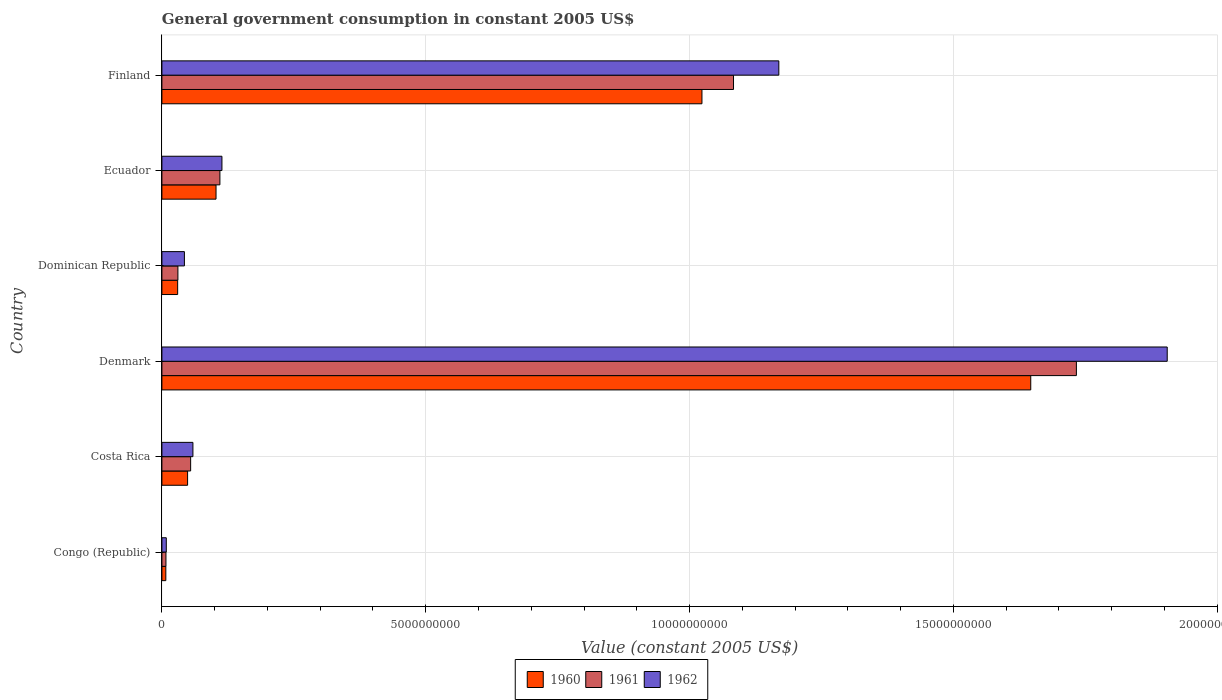How many different coloured bars are there?
Offer a very short reply. 3. How many groups of bars are there?
Your answer should be very brief. 6. How many bars are there on the 4th tick from the bottom?
Offer a very short reply. 3. In how many cases, is the number of bars for a given country not equal to the number of legend labels?
Your answer should be very brief. 0. What is the government conusmption in 1960 in Congo (Republic)?
Provide a succinct answer. 7.44e+07. Across all countries, what is the maximum government conusmption in 1961?
Provide a succinct answer. 1.73e+1. Across all countries, what is the minimum government conusmption in 1960?
Your response must be concise. 7.44e+07. In which country was the government conusmption in 1960 minimum?
Offer a very short reply. Congo (Republic). What is the total government conusmption in 1962 in the graph?
Your answer should be very brief. 3.30e+1. What is the difference between the government conusmption in 1961 in Congo (Republic) and that in Costa Rica?
Offer a very short reply. -4.68e+08. What is the difference between the government conusmption in 1962 in Denmark and the government conusmption in 1961 in Ecuador?
Offer a terse response. 1.80e+1. What is the average government conusmption in 1960 per country?
Offer a very short reply. 4.76e+09. What is the difference between the government conusmption in 1962 and government conusmption in 1960 in Dominican Republic?
Offer a very short reply. 1.28e+08. In how many countries, is the government conusmption in 1962 greater than 14000000000 US$?
Make the answer very short. 1. What is the ratio of the government conusmption in 1960 in Dominican Republic to that in Ecuador?
Offer a very short reply. 0.29. Is the government conusmption in 1960 in Costa Rica less than that in Denmark?
Offer a terse response. Yes. Is the difference between the government conusmption in 1962 in Dominican Republic and Ecuador greater than the difference between the government conusmption in 1960 in Dominican Republic and Ecuador?
Provide a succinct answer. Yes. What is the difference between the highest and the second highest government conusmption in 1962?
Provide a succinct answer. 7.36e+09. What is the difference between the highest and the lowest government conusmption in 1960?
Ensure brevity in your answer.  1.64e+1. In how many countries, is the government conusmption in 1960 greater than the average government conusmption in 1960 taken over all countries?
Make the answer very short. 2. What does the 3rd bar from the top in Dominican Republic represents?
Ensure brevity in your answer.  1960. How many countries are there in the graph?
Ensure brevity in your answer.  6. Are the values on the major ticks of X-axis written in scientific E-notation?
Provide a succinct answer. No. Does the graph contain any zero values?
Provide a short and direct response. No. Where does the legend appear in the graph?
Provide a succinct answer. Bottom center. What is the title of the graph?
Keep it short and to the point. General government consumption in constant 2005 US$. Does "1975" appear as one of the legend labels in the graph?
Offer a very short reply. No. What is the label or title of the X-axis?
Give a very brief answer. Value (constant 2005 US$). What is the Value (constant 2005 US$) of 1960 in Congo (Republic)?
Offer a very short reply. 7.44e+07. What is the Value (constant 2005 US$) in 1961 in Congo (Republic)?
Offer a very short reply. 7.67e+07. What is the Value (constant 2005 US$) in 1962 in Congo (Republic)?
Provide a succinct answer. 8.33e+07. What is the Value (constant 2005 US$) of 1960 in Costa Rica?
Your answer should be compact. 4.87e+08. What is the Value (constant 2005 US$) of 1961 in Costa Rica?
Your answer should be very brief. 5.45e+08. What is the Value (constant 2005 US$) of 1962 in Costa Rica?
Give a very brief answer. 5.88e+08. What is the Value (constant 2005 US$) in 1960 in Denmark?
Offer a very short reply. 1.65e+1. What is the Value (constant 2005 US$) in 1961 in Denmark?
Ensure brevity in your answer.  1.73e+1. What is the Value (constant 2005 US$) of 1962 in Denmark?
Your response must be concise. 1.91e+1. What is the Value (constant 2005 US$) of 1960 in Dominican Republic?
Provide a succinct answer. 2.99e+08. What is the Value (constant 2005 US$) of 1961 in Dominican Republic?
Your response must be concise. 3.03e+08. What is the Value (constant 2005 US$) of 1962 in Dominican Republic?
Offer a very short reply. 4.27e+08. What is the Value (constant 2005 US$) in 1960 in Ecuador?
Make the answer very short. 1.03e+09. What is the Value (constant 2005 US$) in 1961 in Ecuador?
Give a very brief answer. 1.10e+09. What is the Value (constant 2005 US$) in 1962 in Ecuador?
Your response must be concise. 1.14e+09. What is the Value (constant 2005 US$) of 1960 in Finland?
Provide a succinct answer. 1.02e+1. What is the Value (constant 2005 US$) in 1961 in Finland?
Provide a succinct answer. 1.08e+1. What is the Value (constant 2005 US$) of 1962 in Finland?
Offer a terse response. 1.17e+1. Across all countries, what is the maximum Value (constant 2005 US$) in 1960?
Keep it short and to the point. 1.65e+1. Across all countries, what is the maximum Value (constant 2005 US$) in 1961?
Provide a short and direct response. 1.73e+1. Across all countries, what is the maximum Value (constant 2005 US$) of 1962?
Your response must be concise. 1.91e+1. Across all countries, what is the minimum Value (constant 2005 US$) of 1960?
Make the answer very short. 7.44e+07. Across all countries, what is the minimum Value (constant 2005 US$) of 1961?
Ensure brevity in your answer.  7.67e+07. Across all countries, what is the minimum Value (constant 2005 US$) in 1962?
Ensure brevity in your answer.  8.33e+07. What is the total Value (constant 2005 US$) of 1960 in the graph?
Your answer should be very brief. 2.86e+1. What is the total Value (constant 2005 US$) of 1961 in the graph?
Provide a succinct answer. 3.02e+1. What is the total Value (constant 2005 US$) in 1962 in the graph?
Give a very brief answer. 3.30e+1. What is the difference between the Value (constant 2005 US$) of 1960 in Congo (Republic) and that in Costa Rica?
Keep it short and to the point. -4.12e+08. What is the difference between the Value (constant 2005 US$) of 1961 in Congo (Republic) and that in Costa Rica?
Offer a terse response. -4.68e+08. What is the difference between the Value (constant 2005 US$) of 1962 in Congo (Republic) and that in Costa Rica?
Provide a short and direct response. -5.05e+08. What is the difference between the Value (constant 2005 US$) in 1960 in Congo (Republic) and that in Denmark?
Offer a very short reply. -1.64e+1. What is the difference between the Value (constant 2005 US$) of 1961 in Congo (Republic) and that in Denmark?
Your answer should be very brief. -1.73e+1. What is the difference between the Value (constant 2005 US$) in 1962 in Congo (Republic) and that in Denmark?
Your answer should be very brief. -1.90e+1. What is the difference between the Value (constant 2005 US$) in 1960 in Congo (Republic) and that in Dominican Republic?
Offer a very short reply. -2.24e+08. What is the difference between the Value (constant 2005 US$) of 1961 in Congo (Republic) and that in Dominican Republic?
Your answer should be compact. -2.27e+08. What is the difference between the Value (constant 2005 US$) of 1962 in Congo (Republic) and that in Dominican Republic?
Your answer should be very brief. -3.43e+08. What is the difference between the Value (constant 2005 US$) of 1960 in Congo (Republic) and that in Ecuador?
Your response must be concise. -9.51e+08. What is the difference between the Value (constant 2005 US$) of 1961 in Congo (Republic) and that in Ecuador?
Your answer should be very brief. -1.02e+09. What is the difference between the Value (constant 2005 US$) of 1962 in Congo (Republic) and that in Ecuador?
Offer a terse response. -1.05e+09. What is the difference between the Value (constant 2005 US$) in 1960 in Congo (Republic) and that in Finland?
Offer a terse response. -1.02e+1. What is the difference between the Value (constant 2005 US$) of 1961 in Congo (Republic) and that in Finland?
Your answer should be compact. -1.08e+1. What is the difference between the Value (constant 2005 US$) in 1962 in Congo (Republic) and that in Finland?
Make the answer very short. -1.16e+1. What is the difference between the Value (constant 2005 US$) in 1960 in Costa Rica and that in Denmark?
Your response must be concise. -1.60e+1. What is the difference between the Value (constant 2005 US$) in 1961 in Costa Rica and that in Denmark?
Your answer should be very brief. -1.68e+1. What is the difference between the Value (constant 2005 US$) in 1962 in Costa Rica and that in Denmark?
Your answer should be very brief. -1.85e+1. What is the difference between the Value (constant 2005 US$) in 1960 in Costa Rica and that in Dominican Republic?
Your response must be concise. 1.88e+08. What is the difference between the Value (constant 2005 US$) in 1961 in Costa Rica and that in Dominican Republic?
Your answer should be very brief. 2.41e+08. What is the difference between the Value (constant 2005 US$) in 1962 in Costa Rica and that in Dominican Republic?
Your response must be concise. 1.61e+08. What is the difference between the Value (constant 2005 US$) in 1960 in Costa Rica and that in Ecuador?
Offer a terse response. -5.39e+08. What is the difference between the Value (constant 2005 US$) in 1961 in Costa Rica and that in Ecuador?
Provide a succinct answer. -5.55e+08. What is the difference between the Value (constant 2005 US$) of 1962 in Costa Rica and that in Ecuador?
Your response must be concise. -5.50e+08. What is the difference between the Value (constant 2005 US$) in 1960 in Costa Rica and that in Finland?
Offer a very short reply. -9.75e+09. What is the difference between the Value (constant 2005 US$) in 1961 in Costa Rica and that in Finland?
Keep it short and to the point. -1.03e+1. What is the difference between the Value (constant 2005 US$) in 1962 in Costa Rica and that in Finland?
Your answer should be very brief. -1.11e+1. What is the difference between the Value (constant 2005 US$) in 1960 in Denmark and that in Dominican Republic?
Keep it short and to the point. 1.62e+1. What is the difference between the Value (constant 2005 US$) in 1961 in Denmark and that in Dominican Republic?
Keep it short and to the point. 1.70e+1. What is the difference between the Value (constant 2005 US$) in 1962 in Denmark and that in Dominican Republic?
Offer a terse response. 1.86e+1. What is the difference between the Value (constant 2005 US$) of 1960 in Denmark and that in Ecuador?
Provide a short and direct response. 1.54e+1. What is the difference between the Value (constant 2005 US$) of 1961 in Denmark and that in Ecuador?
Your answer should be compact. 1.62e+1. What is the difference between the Value (constant 2005 US$) of 1962 in Denmark and that in Ecuador?
Offer a terse response. 1.79e+1. What is the difference between the Value (constant 2005 US$) of 1960 in Denmark and that in Finland?
Ensure brevity in your answer.  6.23e+09. What is the difference between the Value (constant 2005 US$) in 1961 in Denmark and that in Finland?
Offer a terse response. 6.50e+09. What is the difference between the Value (constant 2005 US$) in 1962 in Denmark and that in Finland?
Offer a very short reply. 7.36e+09. What is the difference between the Value (constant 2005 US$) of 1960 in Dominican Republic and that in Ecuador?
Keep it short and to the point. -7.27e+08. What is the difference between the Value (constant 2005 US$) in 1961 in Dominican Republic and that in Ecuador?
Provide a short and direct response. -7.96e+08. What is the difference between the Value (constant 2005 US$) of 1962 in Dominican Republic and that in Ecuador?
Make the answer very short. -7.11e+08. What is the difference between the Value (constant 2005 US$) of 1960 in Dominican Republic and that in Finland?
Your answer should be compact. -9.94e+09. What is the difference between the Value (constant 2005 US$) in 1961 in Dominican Republic and that in Finland?
Provide a short and direct response. -1.05e+1. What is the difference between the Value (constant 2005 US$) in 1962 in Dominican Republic and that in Finland?
Provide a succinct answer. -1.13e+1. What is the difference between the Value (constant 2005 US$) of 1960 in Ecuador and that in Finland?
Provide a succinct answer. -9.21e+09. What is the difference between the Value (constant 2005 US$) of 1961 in Ecuador and that in Finland?
Your answer should be compact. -9.73e+09. What is the difference between the Value (constant 2005 US$) in 1962 in Ecuador and that in Finland?
Give a very brief answer. -1.06e+1. What is the difference between the Value (constant 2005 US$) of 1960 in Congo (Republic) and the Value (constant 2005 US$) of 1961 in Costa Rica?
Offer a very short reply. -4.70e+08. What is the difference between the Value (constant 2005 US$) of 1960 in Congo (Republic) and the Value (constant 2005 US$) of 1962 in Costa Rica?
Offer a very short reply. -5.13e+08. What is the difference between the Value (constant 2005 US$) of 1961 in Congo (Republic) and the Value (constant 2005 US$) of 1962 in Costa Rica?
Give a very brief answer. -5.11e+08. What is the difference between the Value (constant 2005 US$) of 1960 in Congo (Republic) and the Value (constant 2005 US$) of 1961 in Denmark?
Provide a short and direct response. -1.73e+1. What is the difference between the Value (constant 2005 US$) of 1960 in Congo (Republic) and the Value (constant 2005 US$) of 1962 in Denmark?
Your answer should be compact. -1.90e+1. What is the difference between the Value (constant 2005 US$) in 1961 in Congo (Republic) and the Value (constant 2005 US$) in 1962 in Denmark?
Provide a succinct answer. -1.90e+1. What is the difference between the Value (constant 2005 US$) in 1960 in Congo (Republic) and the Value (constant 2005 US$) in 1961 in Dominican Republic?
Offer a very short reply. -2.29e+08. What is the difference between the Value (constant 2005 US$) in 1960 in Congo (Republic) and the Value (constant 2005 US$) in 1962 in Dominican Republic?
Offer a very short reply. -3.52e+08. What is the difference between the Value (constant 2005 US$) of 1961 in Congo (Republic) and the Value (constant 2005 US$) of 1962 in Dominican Republic?
Your answer should be very brief. -3.50e+08. What is the difference between the Value (constant 2005 US$) of 1960 in Congo (Republic) and the Value (constant 2005 US$) of 1961 in Ecuador?
Keep it short and to the point. -1.02e+09. What is the difference between the Value (constant 2005 US$) in 1960 in Congo (Republic) and the Value (constant 2005 US$) in 1962 in Ecuador?
Offer a terse response. -1.06e+09. What is the difference between the Value (constant 2005 US$) in 1961 in Congo (Republic) and the Value (constant 2005 US$) in 1962 in Ecuador?
Your response must be concise. -1.06e+09. What is the difference between the Value (constant 2005 US$) in 1960 in Congo (Republic) and the Value (constant 2005 US$) in 1961 in Finland?
Provide a short and direct response. -1.08e+1. What is the difference between the Value (constant 2005 US$) of 1960 in Congo (Republic) and the Value (constant 2005 US$) of 1962 in Finland?
Your answer should be compact. -1.16e+1. What is the difference between the Value (constant 2005 US$) of 1961 in Congo (Republic) and the Value (constant 2005 US$) of 1962 in Finland?
Offer a terse response. -1.16e+1. What is the difference between the Value (constant 2005 US$) of 1960 in Costa Rica and the Value (constant 2005 US$) of 1961 in Denmark?
Your response must be concise. -1.68e+1. What is the difference between the Value (constant 2005 US$) of 1960 in Costa Rica and the Value (constant 2005 US$) of 1962 in Denmark?
Your answer should be very brief. -1.86e+1. What is the difference between the Value (constant 2005 US$) in 1961 in Costa Rica and the Value (constant 2005 US$) in 1962 in Denmark?
Ensure brevity in your answer.  -1.85e+1. What is the difference between the Value (constant 2005 US$) of 1960 in Costa Rica and the Value (constant 2005 US$) of 1961 in Dominican Republic?
Keep it short and to the point. 1.83e+08. What is the difference between the Value (constant 2005 US$) in 1960 in Costa Rica and the Value (constant 2005 US$) in 1962 in Dominican Republic?
Provide a short and direct response. 6.01e+07. What is the difference between the Value (constant 2005 US$) in 1961 in Costa Rica and the Value (constant 2005 US$) in 1962 in Dominican Republic?
Your answer should be very brief. 1.18e+08. What is the difference between the Value (constant 2005 US$) of 1960 in Costa Rica and the Value (constant 2005 US$) of 1961 in Ecuador?
Your answer should be very brief. -6.13e+08. What is the difference between the Value (constant 2005 US$) in 1960 in Costa Rica and the Value (constant 2005 US$) in 1962 in Ecuador?
Offer a very short reply. -6.51e+08. What is the difference between the Value (constant 2005 US$) in 1961 in Costa Rica and the Value (constant 2005 US$) in 1962 in Ecuador?
Make the answer very short. -5.93e+08. What is the difference between the Value (constant 2005 US$) in 1960 in Costa Rica and the Value (constant 2005 US$) in 1961 in Finland?
Keep it short and to the point. -1.03e+1. What is the difference between the Value (constant 2005 US$) of 1960 in Costa Rica and the Value (constant 2005 US$) of 1962 in Finland?
Keep it short and to the point. -1.12e+1. What is the difference between the Value (constant 2005 US$) of 1961 in Costa Rica and the Value (constant 2005 US$) of 1962 in Finland?
Provide a short and direct response. -1.11e+1. What is the difference between the Value (constant 2005 US$) of 1960 in Denmark and the Value (constant 2005 US$) of 1961 in Dominican Republic?
Offer a very short reply. 1.62e+1. What is the difference between the Value (constant 2005 US$) of 1960 in Denmark and the Value (constant 2005 US$) of 1962 in Dominican Republic?
Provide a succinct answer. 1.60e+1. What is the difference between the Value (constant 2005 US$) of 1961 in Denmark and the Value (constant 2005 US$) of 1962 in Dominican Republic?
Offer a terse response. 1.69e+1. What is the difference between the Value (constant 2005 US$) in 1960 in Denmark and the Value (constant 2005 US$) in 1961 in Ecuador?
Your answer should be very brief. 1.54e+1. What is the difference between the Value (constant 2005 US$) of 1960 in Denmark and the Value (constant 2005 US$) of 1962 in Ecuador?
Keep it short and to the point. 1.53e+1. What is the difference between the Value (constant 2005 US$) of 1961 in Denmark and the Value (constant 2005 US$) of 1962 in Ecuador?
Your answer should be compact. 1.62e+1. What is the difference between the Value (constant 2005 US$) of 1960 in Denmark and the Value (constant 2005 US$) of 1961 in Finland?
Give a very brief answer. 5.63e+09. What is the difference between the Value (constant 2005 US$) in 1960 in Denmark and the Value (constant 2005 US$) in 1962 in Finland?
Offer a very short reply. 4.77e+09. What is the difference between the Value (constant 2005 US$) of 1961 in Denmark and the Value (constant 2005 US$) of 1962 in Finland?
Keep it short and to the point. 5.64e+09. What is the difference between the Value (constant 2005 US$) in 1960 in Dominican Republic and the Value (constant 2005 US$) in 1961 in Ecuador?
Provide a short and direct response. -8.01e+08. What is the difference between the Value (constant 2005 US$) of 1960 in Dominican Republic and the Value (constant 2005 US$) of 1962 in Ecuador?
Keep it short and to the point. -8.39e+08. What is the difference between the Value (constant 2005 US$) in 1961 in Dominican Republic and the Value (constant 2005 US$) in 1962 in Ecuador?
Keep it short and to the point. -8.35e+08. What is the difference between the Value (constant 2005 US$) in 1960 in Dominican Republic and the Value (constant 2005 US$) in 1961 in Finland?
Make the answer very short. -1.05e+1. What is the difference between the Value (constant 2005 US$) of 1960 in Dominican Republic and the Value (constant 2005 US$) of 1962 in Finland?
Your answer should be compact. -1.14e+1. What is the difference between the Value (constant 2005 US$) in 1961 in Dominican Republic and the Value (constant 2005 US$) in 1962 in Finland?
Provide a short and direct response. -1.14e+1. What is the difference between the Value (constant 2005 US$) of 1960 in Ecuador and the Value (constant 2005 US$) of 1961 in Finland?
Ensure brevity in your answer.  -9.81e+09. What is the difference between the Value (constant 2005 US$) in 1960 in Ecuador and the Value (constant 2005 US$) in 1962 in Finland?
Your answer should be compact. -1.07e+1. What is the difference between the Value (constant 2005 US$) of 1961 in Ecuador and the Value (constant 2005 US$) of 1962 in Finland?
Offer a terse response. -1.06e+1. What is the average Value (constant 2005 US$) of 1960 per country?
Make the answer very short. 4.76e+09. What is the average Value (constant 2005 US$) of 1961 per country?
Keep it short and to the point. 5.03e+09. What is the average Value (constant 2005 US$) in 1962 per country?
Offer a terse response. 5.50e+09. What is the difference between the Value (constant 2005 US$) in 1960 and Value (constant 2005 US$) in 1961 in Congo (Republic)?
Provide a short and direct response. -2.22e+06. What is the difference between the Value (constant 2005 US$) of 1960 and Value (constant 2005 US$) of 1962 in Congo (Republic)?
Provide a succinct answer. -8.89e+06. What is the difference between the Value (constant 2005 US$) of 1961 and Value (constant 2005 US$) of 1962 in Congo (Republic)?
Provide a succinct answer. -6.67e+06. What is the difference between the Value (constant 2005 US$) of 1960 and Value (constant 2005 US$) of 1961 in Costa Rica?
Make the answer very short. -5.79e+07. What is the difference between the Value (constant 2005 US$) in 1960 and Value (constant 2005 US$) in 1962 in Costa Rica?
Make the answer very short. -1.01e+08. What is the difference between the Value (constant 2005 US$) of 1961 and Value (constant 2005 US$) of 1962 in Costa Rica?
Give a very brief answer. -4.32e+07. What is the difference between the Value (constant 2005 US$) in 1960 and Value (constant 2005 US$) in 1961 in Denmark?
Your answer should be compact. -8.65e+08. What is the difference between the Value (constant 2005 US$) in 1960 and Value (constant 2005 US$) in 1962 in Denmark?
Provide a short and direct response. -2.59e+09. What is the difference between the Value (constant 2005 US$) of 1961 and Value (constant 2005 US$) of 1962 in Denmark?
Offer a terse response. -1.72e+09. What is the difference between the Value (constant 2005 US$) in 1960 and Value (constant 2005 US$) in 1961 in Dominican Republic?
Offer a terse response. -4.75e+06. What is the difference between the Value (constant 2005 US$) in 1960 and Value (constant 2005 US$) in 1962 in Dominican Republic?
Provide a succinct answer. -1.28e+08. What is the difference between the Value (constant 2005 US$) in 1961 and Value (constant 2005 US$) in 1962 in Dominican Republic?
Your response must be concise. -1.23e+08. What is the difference between the Value (constant 2005 US$) in 1960 and Value (constant 2005 US$) in 1961 in Ecuador?
Provide a short and direct response. -7.35e+07. What is the difference between the Value (constant 2005 US$) of 1960 and Value (constant 2005 US$) of 1962 in Ecuador?
Provide a short and direct response. -1.12e+08. What is the difference between the Value (constant 2005 US$) of 1961 and Value (constant 2005 US$) of 1962 in Ecuador?
Offer a terse response. -3.85e+07. What is the difference between the Value (constant 2005 US$) in 1960 and Value (constant 2005 US$) in 1961 in Finland?
Offer a very short reply. -5.98e+08. What is the difference between the Value (constant 2005 US$) in 1960 and Value (constant 2005 US$) in 1962 in Finland?
Your answer should be compact. -1.46e+09. What is the difference between the Value (constant 2005 US$) of 1961 and Value (constant 2005 US$) of 1962 in Finland?
Offer a terse response. -8.59e+08. What is the ratio of the Value (constant 2005 US$) in 1960 in Congo (Republic) to that in Costa Rica?
Ensure brevity in your answer.  0.15. What is the ratio of the Value (constant 2005 US$) in 1961 in Congo (Republic) to that in Costa Rica?
Offer a very short reply. 0.14. What is the ratio of the Value (constant 2005 US$) of 1962 in Congo (Republic) to that in Costa Rica?
Provide a succinct answer. 0.14. What is the ratio of the Value (constant 2005 US$) in 1960 in Congo (Republic) to that in Denmark?
Make the answer very short. 0. What is the ratio of the Value (constant 2005 US$) of 1961 in Congo (Republic) to that in Denmark?
Your answer should be very brief. 0. What is the ratio of the Value (constant 2005 US$) of 1962 in Congo (Republic) to that in Denmark?
Provide a short and direct response. 0. What is the ratio of the Value (constant 2005 US$) of 1960 in Congo (Republic) to that in Dominican Republic?
Make the answer very short. 0.25. What is the ratio of the Value (constant 2005 US$) of 1961 in Congo (Republic) to that in Dominican Republic?
Your answer should be very brief. 0.25. What is the ratio of the Value (constant 2005 US$) in 1962 in Congo (Republic) to that in Dominican Republic?
Provide a succinct answer. 0.2. What is the ratio of the Value (constant 2005 US$) in 1960 in Congo (Republic) to that in Ecuador?
Keep it short and to the point. 0.07. What is the ratio of the Value (constant 2005 US$) of 1961 in Congo (Republic) to that in Ecuador?
Provide a succinct answer. 0.07. What is the ratio of the Value (constant 2005 US$) of 1962 in Congo (Republic) to that in Ecuador?
Offer a very short reply. 0.07. What is the ratio of the Value (constant 2005 US$) in 1960 in Congo (Republic) to that in Finland?
Offer a very short reply. 0.01. What is the ratio of the Value (constant 2005 US$) in 1961 in Congo (Republic) to that in Finland?
Offer a terse response. 0.01. What is the ratio of the Value (constant 2005 US$) of 1962 in Congo (Republic) to that in Finland?
Your answer should be very brief. 0.01. What is the ratio of the Value (constant 2005 US$) of 1960 in Costa Rica to that in Denmark?
Provide a succinct answer. 0.03. What is the ratio of the Value (constant 2005 US$) in 1961 in Costa Rica to that in Denmark?
Give a very brief answer. 0.03. What is the ratio of the Value (constant 2005 US$) in 1962 in Costa Rica to that in Denmark?
Give a very brief answer. 0.03. What is the ratio of the Value (constant 2005 US$) in 1960 in Costa Rica to that in Dominican Republic?
Keep it short and to the point. 1.63. What is the ratio of the Value (constant 2005 US$) of 1961 in Costa Rica to that in Dominican Republic?
Your response must be concise. 1.8. What is the ratio of the Value (constant 2005 US$) in 1962 in Costa Rica to that in Dominican Republic?
Provide a succinct answer. 1.38. What is the ratio of the Value (constant 2005 US$) in 1960 in Costa Rica to that in Ecuador?
Provide a short and direct response. 0.47. What is the ratio of the Value (constant 2005 US$) in 1961 in Costa Rica to that in Ecuador?
Offer a very short reply. 0.5. What is the ratio of the Value (constant 2005 US$) of 1962 in Costa Rica to that in Ecuador?
Provide a succinct answer. 0.52. What is the ratio of the Value (constant 2005 US$) of 1960 in Costa Rica to that in Finland?
Your response must be concise. 0.05. What is the ratio of the Value (constant 2005 US$) of 1961 in Costa Rica to that in Finland?
Keep it short and to the point. 0.05. What is the ratio of the Value (constant 2005 US$) of 1962 in Costa Rica to that in Finland?
Your answer should be compact. 0.05. What is the ratio of the Value (constant 2005 US$) in 1960 in Denmark to that in Dominican Republic?
Ensure brevity in your answer.  55.14. What is the ratio of the Value (constant 2005 US$) in 1961 in Denmark to that in Dominican Republic?
Provide a short and direct response. 57.13. What is the ratio of the Value (constant 2005 US$) of 1962 in Denmark to that in Dominican Republic?
Provide a short and direct response. 44.66. What is the ratio of the Value (constant 2005 US$) of 1960 in Denmark to that in Ecuador?
Provide a succinct answer. 16.05. What is the ratio of the Value (constant 2005 US$) of 1961 in Denmark to that in Ecuador?
Make the answer very short. 15.76. What is the ratio of the Value (constant 2005 US$) of 1962 in Denmark to that in Ecuador?
Your answer should be very brief. 16.74. What is the ratio of the Value (constant 2005 US$) in 1960 in Denmark to that in Finland?
Keep it short and to the point. 1.61. What is the ratio of the Value (constant 2005 US$) in 1961 in Denmark to that in Finland?
Give a very brief answer. 1.6. What is the ratio of the Value (constant 2005 US$) in 1962 in Denmark to that in Finland?
Your response must be concise. 1.63. What is the ratio of the Value (constant 2005 US$) in 1960 in Dominican Republic to that in Ecuador?
Provide a short and direct response. 0.29. What is the ratio of the Value (constant 2005 US$) of 1961 in Dominican Republic to that in Ecuador?
Provide a short and direct response. 0.28. What is the ratio of the Value (constant 2005 US$) of 1962 in Dominican Republic to that in Ecuador?
Provide a short and direct response. 0.37. What is the ratio of the Value (constant 2005 US$) of 1960 in Dominican Republic to that in Finland?
Offer a terse response. 0.03. What is the ratio of the Value (constant 2005 US$) in 1961 in Dominican Republic to that in Finland?
Offer a very short reply. 0.03. What is the ratio of the Value (constant 2005 US$) of 1962 in Dominican Republic to that in Finland?
Your response must be concise. 0.04. What is the ratio of the Value (constant 2005 US$) of 1960 in Ecuador to that in Finland?
Ensure brevity in your answer.  0.1. What is the ratio of the Value (constant 2005 US$) of 1961 in Ecuador to that in Finland?
Your response must be concise. 0.1. What is the ratio of the Value (constant 2005 US$) of 1962 in Ecuador to that in Finland?
Make the answer very short. 0.1. What is the difference between the highest and the second highest Value (constant 2005 US$) of 1960?
Provide a short and direct response. 6.23e+09. What is the difference between the highest and the second highest Value (constant 2005 US$) of 1961?
Give a very brief answer. 6.50e+09. What is the difference between the highest and the second highest Value (constant 2005 US$) of 1962?
Your answer should be very brief. 7.36e+09. What is the difference between the highest and the lowest Value (constant 2005 US$) in 1960?
Ensure brevity in your answer.  1.64e+1. What is the difference between the highest and the lowest Value (constant 2005 US$) in 1961?
Give a very brief answer. 1.73e+1. What is the difference between the highest and the lowest Value (constant 2005 US$) of 1962?
Give a very brief answer. 1.90e+1. 